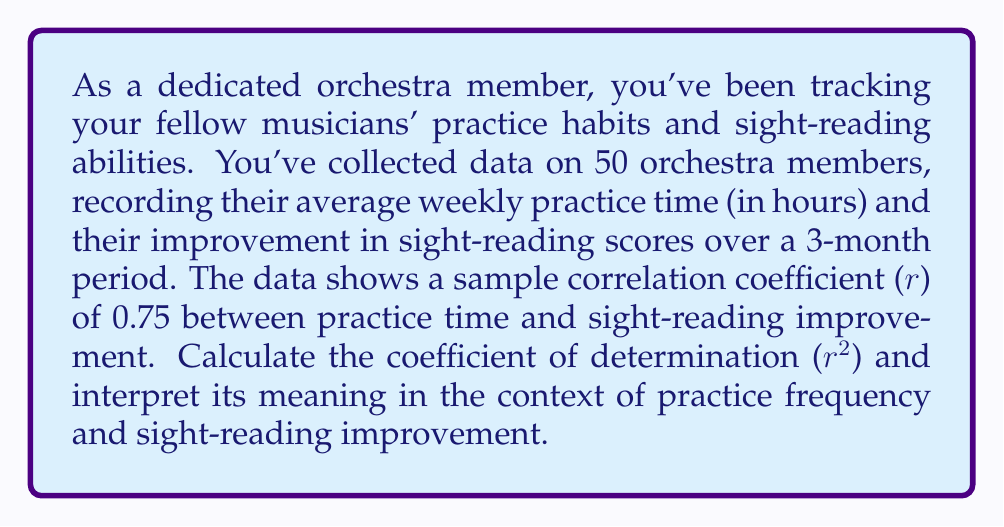Show me your answer to this math problem. To solve this problem, we'll follow these steps:

1) The coefficient of determination (r²) is the square of the correlation coefficient (r).

2) Given:
   Correlation coefficient (r) = 0.75

3) Calculate r²:
   $$r^2 = (0.75)^2 = 0.5625$$

4) Interpretation:
   The coefficient of determination (r²) represents the proportion of the variance in the dependent variable (sight-reading improvement) that is predictable from the independent variable (practice frequency).

   In this case, r² = 0.5625 or 56.25%

   This means that approximately 56.25% of the variation in sight-reading improvement can be explained by the variation in practice frequency.

5) In the context of our orchestra:
   - 56.25% of the differences in sight-reading improvement among the orchestra members can be accounted for by differences in their practice frequency.
   - The remaining 43.75% of the variation is due to other factors not captured by practice frequency alone.

This result suggests a moderate to strong relationship between practice frequency and sight-reading improvement, reinforcing the importance of regular practice for developing sight-reading skills.
Answer: The coefficient of determination (r²) is 0.5625 or 56.25%. This indicates that 56.25% of the variation in sight-reading improvement can be explained by differences in practice frequency among the orchestra members. 